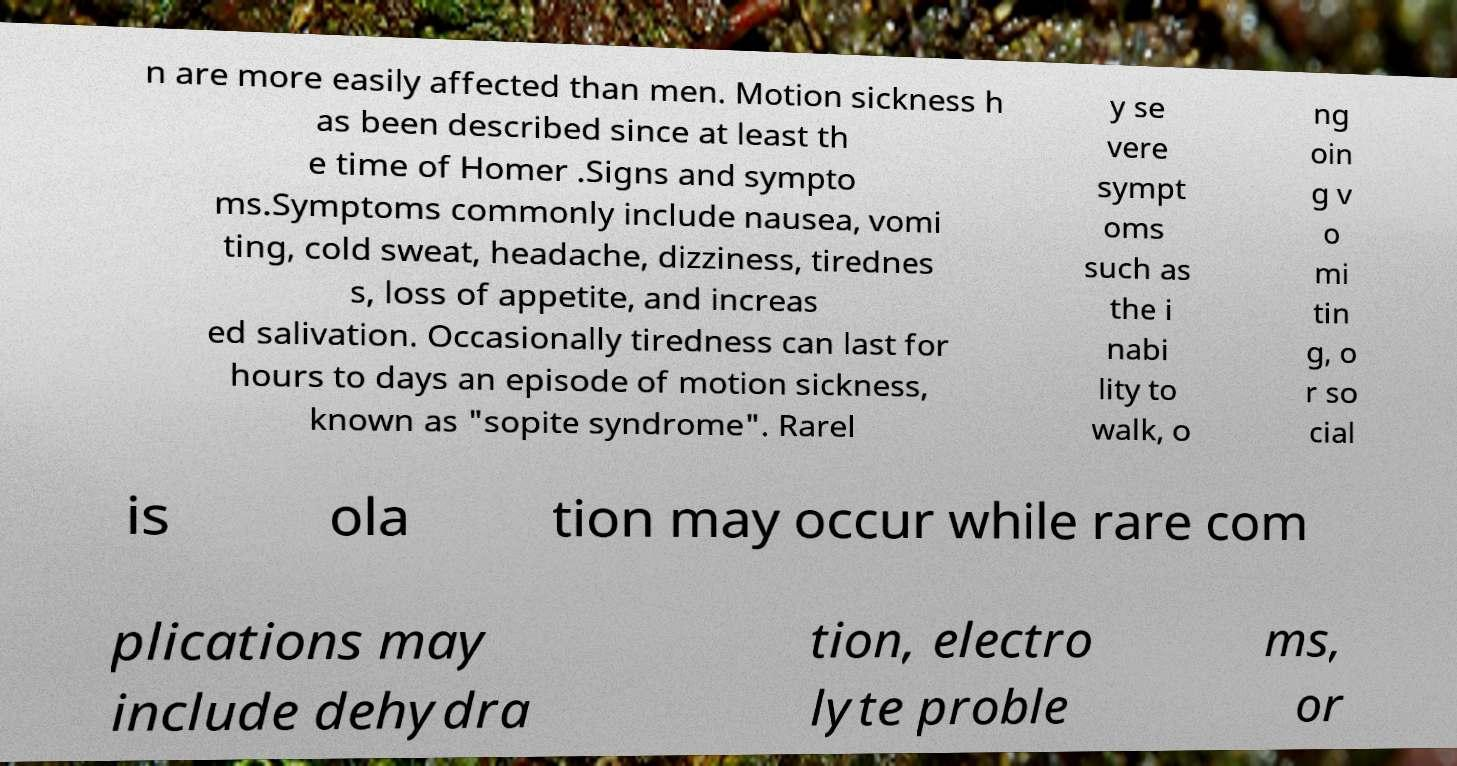I need the written content from this picture converted into text. Can you do that? n are more easily affected than men. Motion sickness h as been described since at least th e time of Homer .Signs and sympto ms.Symptoms commonly include nausea, vomi ting, cold sweat, headache, dizziness, tirednes s, loss of appetite, and increas ed salivation. Occasionally tiredness can last for hours to days an episode of motion sickness, known as "sopite syndrome". Rarel y se vere sympt oms such as the i nabi lity to walk, o ng oin g v o mi tin g, o r so cial is ola tion may occur while rare com plications may include dehydra tion, electro lyte proble ms, or 